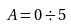<formula> <loc_0><loc_0><loc_500><loc_500>A = 0 \div 5</formula> 